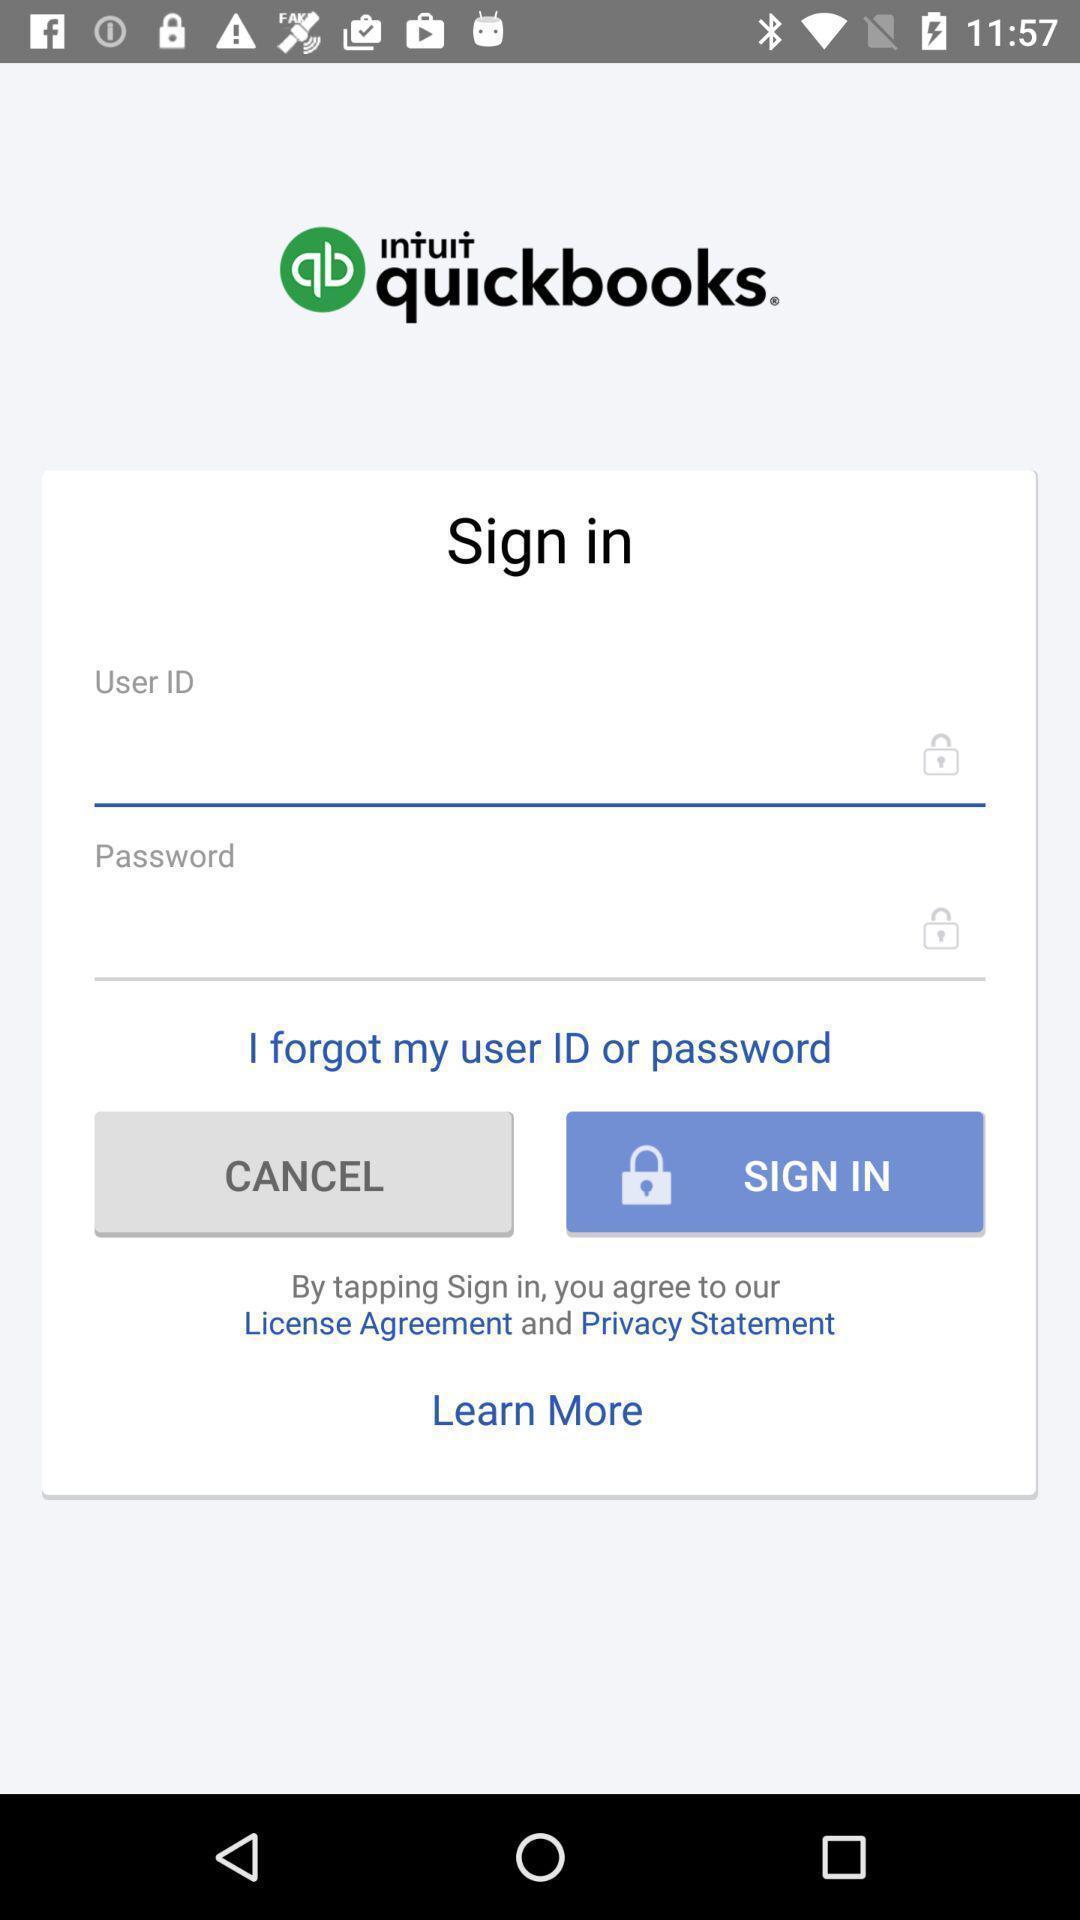Tell me what you see in this picture. Welcome page with login options in an accounting based app. 